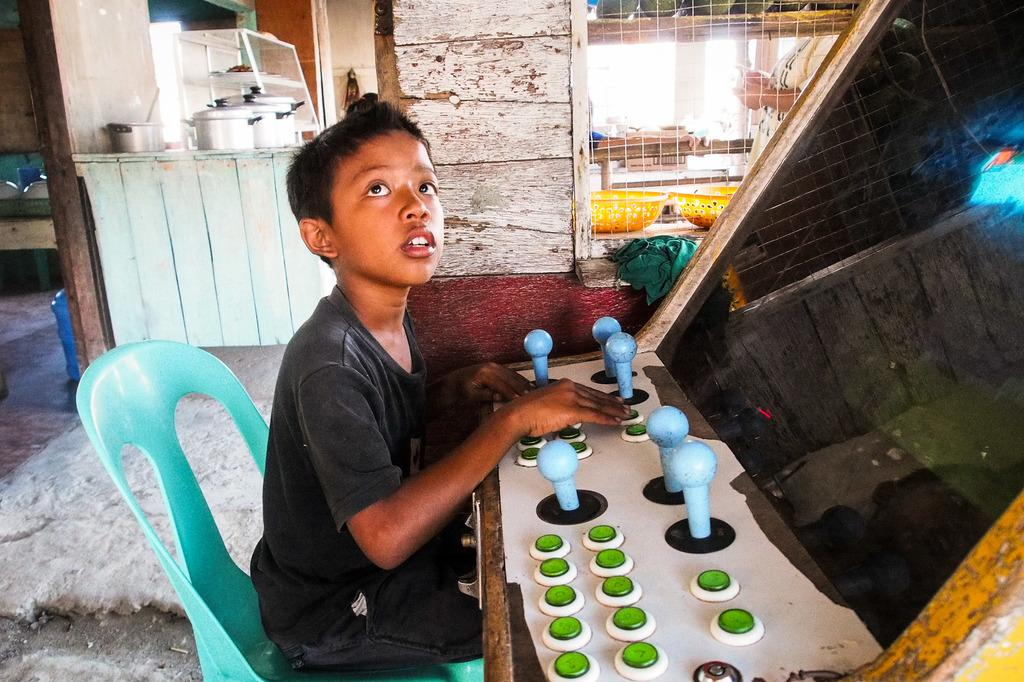What is the kid doing in the image? The kid is sitting on a chair in the image. What can be seen on the right side of the image? There is an object with buttons on the right side of the image. What is visible in the background of the image? There are vessels and a wooden wall in the background of the image. What type of bun can be seen in the field in the image? There is no field or bun present in the image. How many hydrants are visible in the image? There are no hydrants visible in the image. 